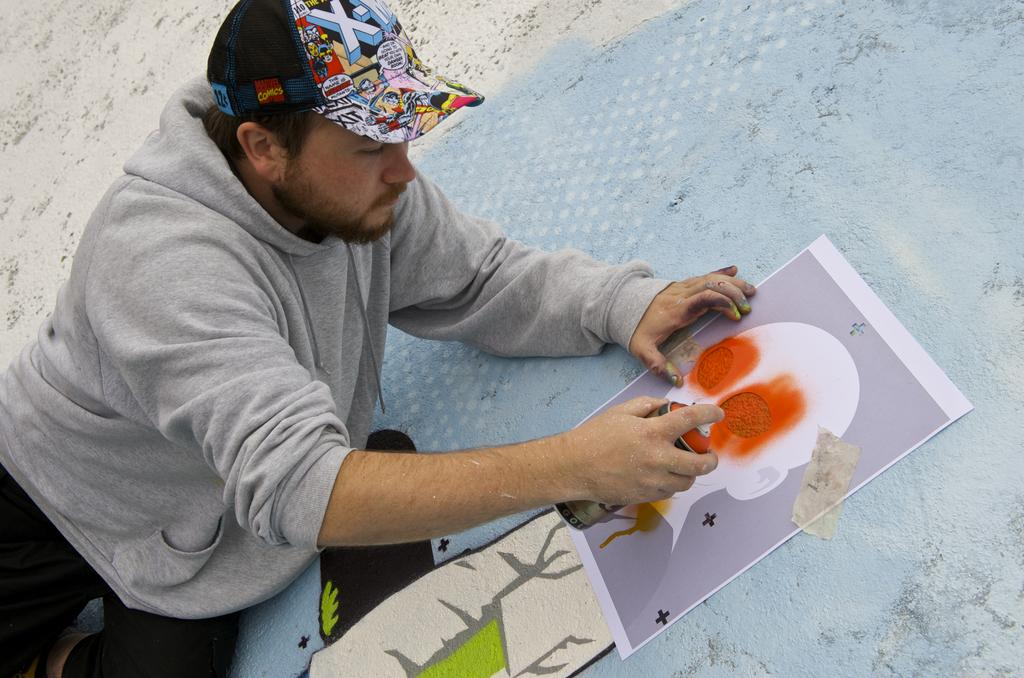Who is present in the image? There is a person in the image. What is the person wearing on their head? The person is wearing a cap. What is the person holding in the image? The person is holding a graffiti bottle. What can be seen in the background of the image? There is a wall and a paper in the background of the image. What is depicted on the wall or paper? There is graffiti on the wall or paper. How many friends does the person have in the image? The image does not show any friends, only the person holding a graffiti bottle. What type of knowledge can be gained from the books in the image? There are no books present in the image, so no knowledge can be gained from them. 